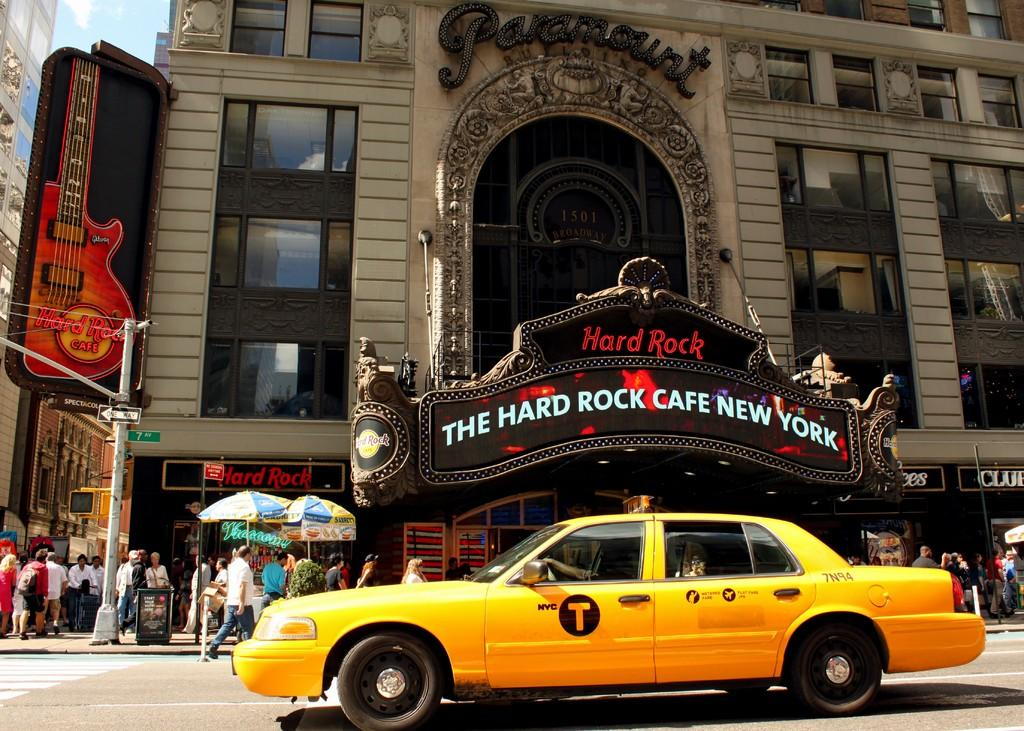Provide a one-sentence caption for the provided image. a taxi next to a hard rock building on its right. 